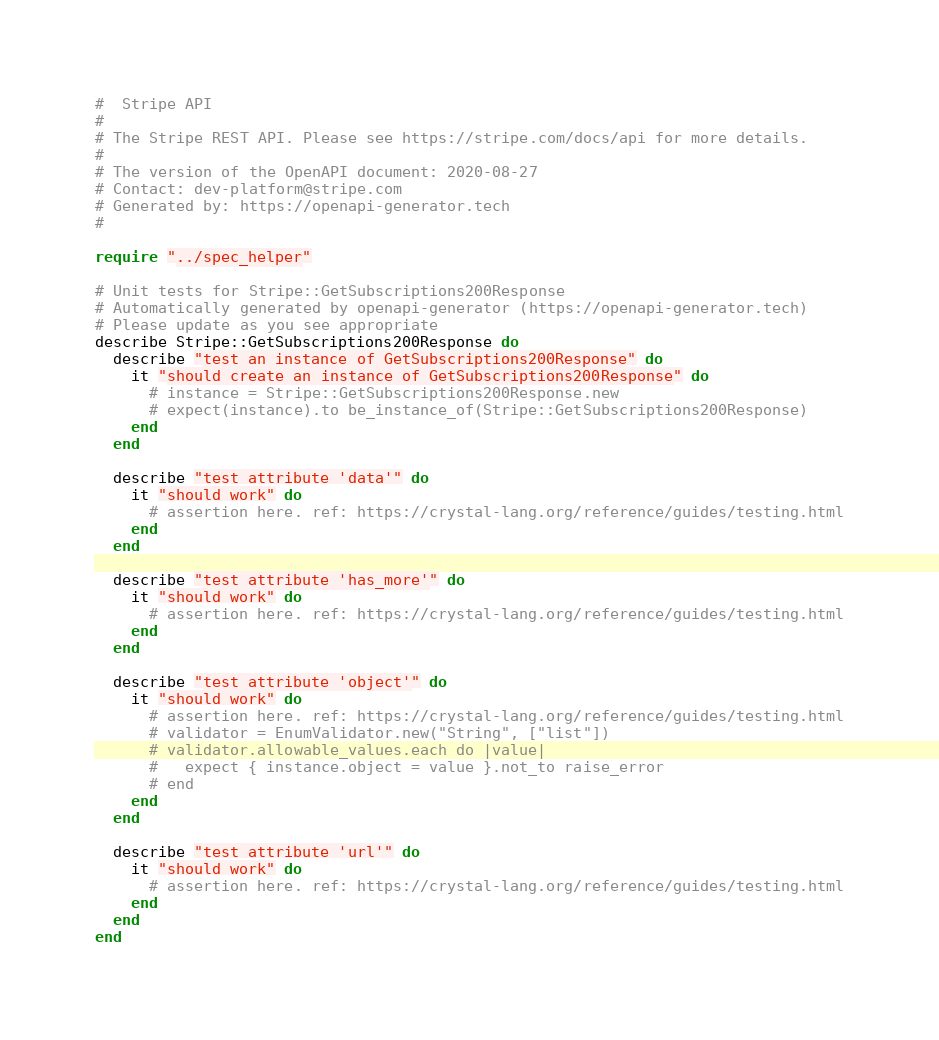Convert code to text. <code><loc_0><loc_0><loc_500><loc_500><_Crystal_>#  Stripe API
#
# The Stripe REST API. Please see https://stripe.com/docs/api for more details.
#
# The version of the OpenAPI document: 2020-08-27
# Contact: dev-platform@stripe.com
# Generated by: https://openapi-generator.tech
#

require "../spec_helper"

# Unit tests for Stripe::GetSubscriptions200Response
# Automatically generated by openapi-generator (https://openapi-generator.tech)
# Please update as you see appropriate
describe Stripe::GetSubscriptions200Response do
  describe "test an instance of GetSubscriptions200Response" do
    it "should create an instance of GetSubscriptions200Response" do
      # instance = Stripe::GetSubscriptions200Response.new
      # expect(instance).to be_instance_of(Stripe::GetSubscriptions200Response)
    end
  end

  describe "test attribute 'data'" do
    it "should work" do
      # assertion here. ref: https://crystal-lang.org/reference/guides/testing.html
    end
  end

  describe "test attribute 'has_more'" do
    it "should work" do
      # assertion here. ref: https://crystal-lang.org/reference/guides/testing.html
    end
  end

  describe "test attribute 'object'" do
    it "should work" do
      # assertion here. ref: https://crystal-lang.org/reference/guides/testing.html
      # validator = EnumValidator.new("String", ["list"])
      # validator.allowable_values.each do |value|
      #   expect { instance.object = value }.not_to raise_error
      # end
    end
  end

  describe "test attribute 'url'" do
    it "should work" do
      # assertion here. ref: https://crystal-lang.org/reference/guides/testing.html
    end
  end
end
</code> 